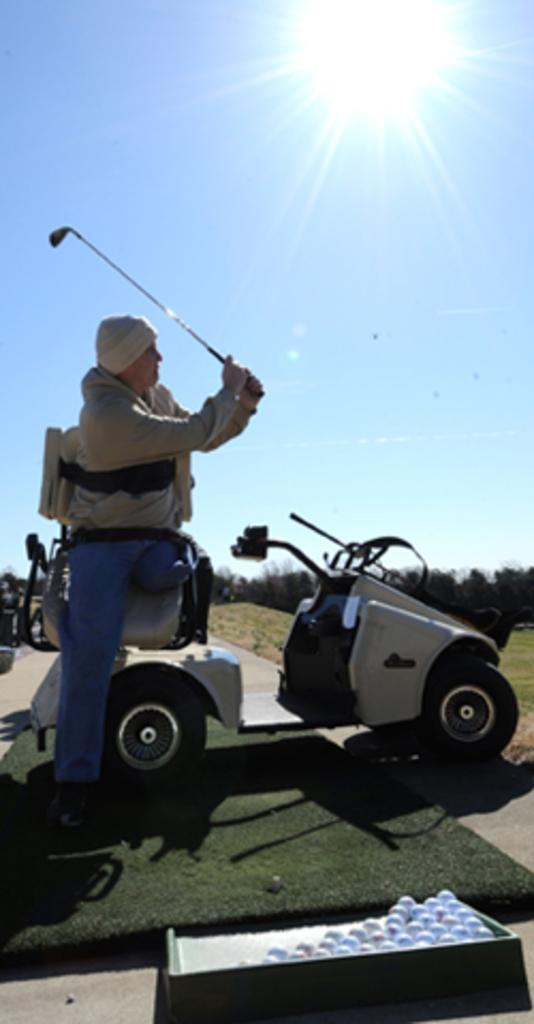Who or what is the main subject in the image? There is a person in the image. What is the person doing in the image? The person is sitting on a vehicle and holding a hockey stick. What objects are in front of the person? There are balls in front of the person. What can be seen in the background of the image? There are trees in the background of the image. What type of corn is growing in the background of the image? There is no corn visible in the image; the background features trees. 